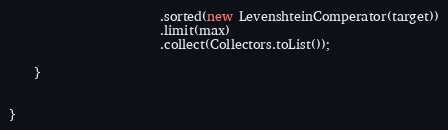Convert code to text. <code><loc_0><loc_0><loc_500><loc_500><_Java_>                        .sorted(new LevenshteinComperator(target))
                        .limit(max)
                        .collect(Collectors.toList());

    }


}
</code> 